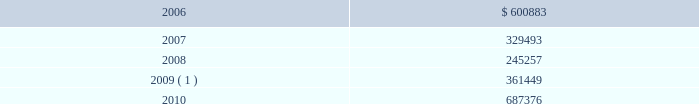During 2005 , we amended our $ 1.0 billion unsecured revolving credit facility to extend its maturity date from march 27 , 2008 to march 27 , 2010 , and reduce the effective interest rate to libor plus 1.0% ( 1.0 % ) and the commitment fee to 0.2% ( 0.2 % ) of the undrawn portion of the facility at december 31 , 2005 .
In addition , in 2005 , we entered into two $ 100.0 million unsecured term loans , due 2010 , at an effective interest rate of libor plus 0.8% ( 0.8 % ) at december 31 , 2005 .
During 2004 , we entered into an eight-year , $ 225.0 million unse- cured term loan , at libor plus 1.75% ( 1.75 % ) , which was amended in 2005 to reduce the effective interest rate to libor plus 1.0% ( 1.0 % ) at december 31 , 2005 .
The liquid yield option 2122 notes and the zero coupon convertible notes are unsecured zero coupon bonds with yields to maturity of 4.875% ( 4.875 % ) and 4.75% ( 4.75 % ) , respectively , due 2021 .
Each liquid yield option 2122 note and zero coupon convertible note was issued at a price of $ 381.63 and $ 391.06 , respectively , and will have a principal amount at maturity of $ 1000 .
Each liquid yield option 2122 note and zero coupon convertible note is convertible at the option of the holder into 11.7152 and 15.6675 shares of common stock , respec- tively , if the market price of our common stock reaches certain lev- els .
These conditions were met at december 31 , 2005 and 2004 for the zero coupon convertible notes and at december 31 , 2004 for the liquid yield option 2122 notes .
Since february 2 , 2005 , we have the right to redeem the liquid yield option 2122 notes and commencing on may 18 , 2006 , we will have the right to redeem the zero coupon con- vertible notes at their accreted values for cash as a whole at any time , or from time to time in part .
Holders may require us to pur- chase any outstanding liquid yield option 2122 notes at their accreted value on february 2 , 2011 and any outstanding zero coupon con- vertible notes at their accreted value on may 18 , 2009 and may 18 , 2014 .
We may choose to pay the purchase price in cash or common stock or a combination thereof .
During 2005 , holders of our liquid yield option 2122 notes and zero coupon convertible notes converted approximately $ 10.4 million and $ 285.0 million , respectively , of the accreted value of these notes into approximately 0.3 million and 9.4 million shares , respec- tively , of our common stock and cash for fractional shares .
In addi- tion , we called for redemption $ 182.3 million of the accreted bal- ance of outstanding liquid yield option 2122 notes .
Most holders of the liquid yield option 2122 notes elected to convert into shares of our common stock , rather than redeem for cash , resulting in the issuance of approximately 4.5 million shares .
During 2005 , we prepaid a total of $ 297.0 million on a term loan secured by a certain celebrity ship and on a variable rate unsecured term loan .
In 1996 , we entered into a $ 264.0 million capital lease to finance splendour of the seas and in 1995 we entered into a $ 260.0 million capital lease to finance legend of the seas .
During 2005 , we paid $ 335.8 million in connection with the exercise of purchase options on these capital lease obligations .
Under certain of our agreements , the contractual interest rate and commitment fee vary with our debt rating .
The unsecured senior notes and senior debentures are not redeemable prior to maturity .
Our debt agreements contain covenants that require us , among other things , to maintain minimum net worth and fixed charge cov- erage ratio and limit our debt to capital ratio .
We are in compliance with all covenants as of december 31 , 2005 .
Following is a schedule of annual maturities on long-term debt as of december 31 , 2005 for each of the next five years ( in thousands ) : .
1 the $ 137.9 million accreted value of the zero coupon convertible notes at december 31 , 2005 is included in year 2009 .
The holders of our zero coupon convertible notes may require us to purchase any notes outstanding at an accreted value of $ 161.7 mil- lion on may 18 , 2009 .
This accreted value was calculated based on the number of notes outstanding at december 31 , 2005 .
We may choose to pay any amounts in cash or common stock or a combination thereof .
Note 6 .
Shareholders 2019 equity on september 25 , 2005 , we announced that we and an investment bank had finalized a forward sale agreement relating to an asr transaction .
As part of the asr transaction , we purchased 5.5 million shares of our common stock from the investment bank at an initial price of $ 45.40 per share .
Total consideration paid to repurchase such shares , including commissions and other fees , was approxi- mately $ 249.1 million and was recorded in shareholders 2019 equity as a component of treasury stock .
The forward sale contract matured in february 2006 .
During the term of the forward sale contract , the investment bank purchased shares of our common stock in the open market to settle its obliga- tion related to the shares borrowed from third parties and sold to us .
Upon settlement of the contract , we received 218089 additional shares of our common stock .
These incremental shares will be recorded in shareholders 2019 equity as a component of treasury stock in the first quarter of 2006 .
Our employee stock purchase plan ( 201cespp 201d ) , which has been in effect since january 1 , 1994 , facilitates the purchase by employees of up to 800000 shares of common stock .
Offerings to employees are made on a quarterly basis .
Subject to certain limitations , the pur- chase price for each share of common stock is equal to 90% ( 90 % ) of the average of the market prices of the common stock as reported on the new york stock exchange on the first business day of the pur- chase period and the last business day of each month of the pur- chase period .
Shares of common stock of 14476 , 13281 and 21280 38 royal caribbean cruises ltd .
Notes to the consolidated financial statements ( continued ) .
What percentage of debt maturity was there in 2010 , relative to 2006? 
Computations: (100 * (687376 / 600883))
Answer: 114.39432. 